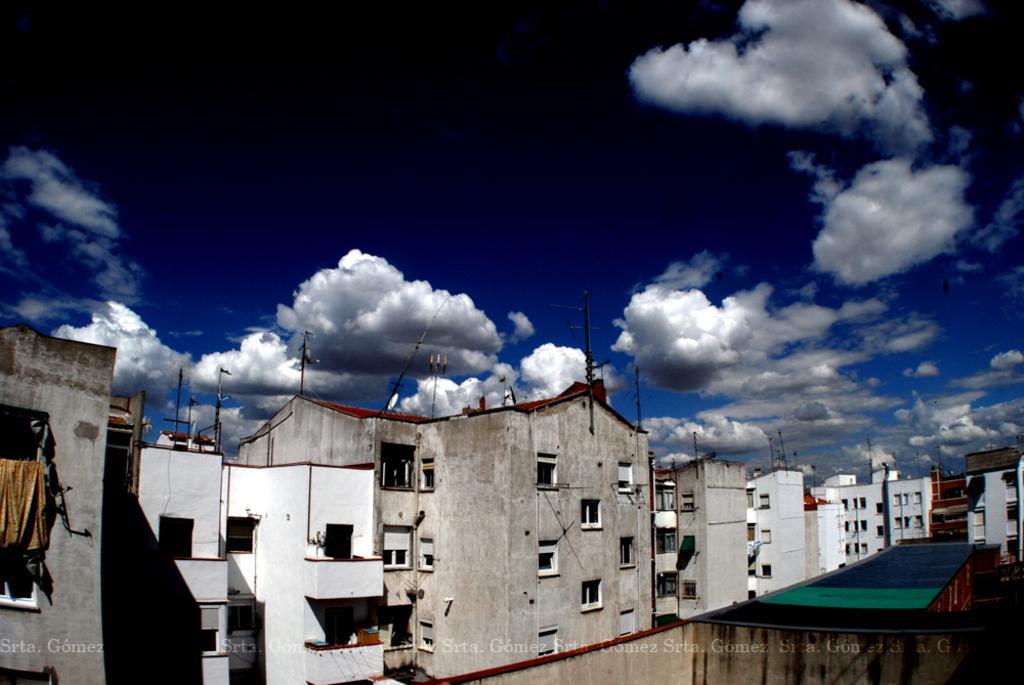Could you give a brief overview of what you see in this image? These are the buildings with windows. I think these are the kind of poles, which are at the top of the building. I can see the clouds in the sky. This looks like a cloth, which is hanging. I can see the watermark on the image. 